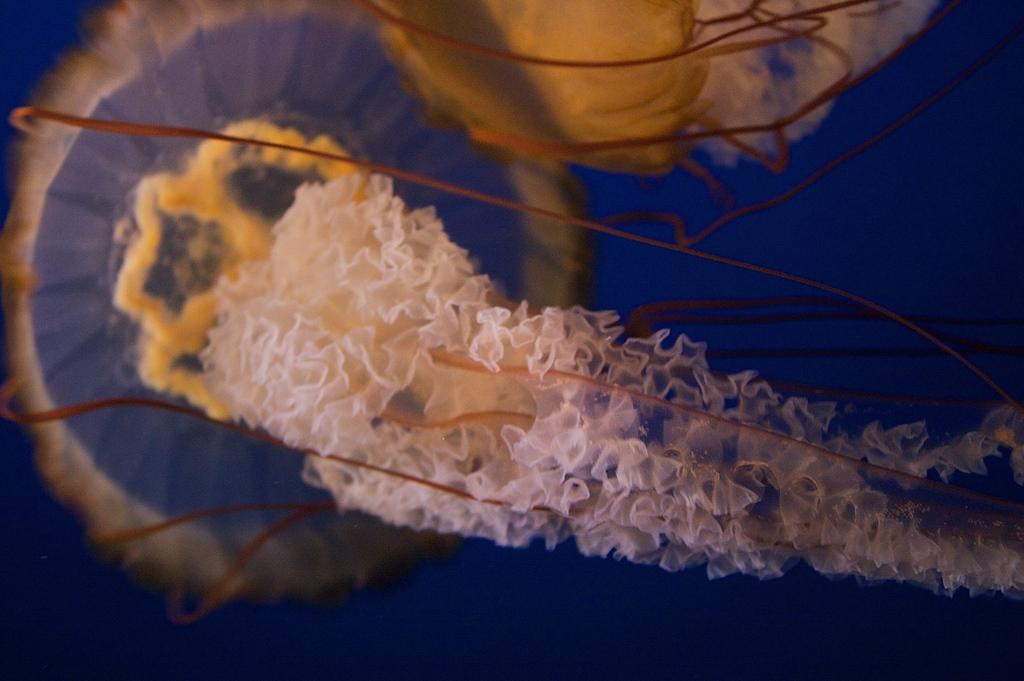What type of marine animals are present in the image? There are two jellyfishes in the image. What verse from a book can be seen in the image? There is no verse from a book present in the image; it features two jellyfishes. 